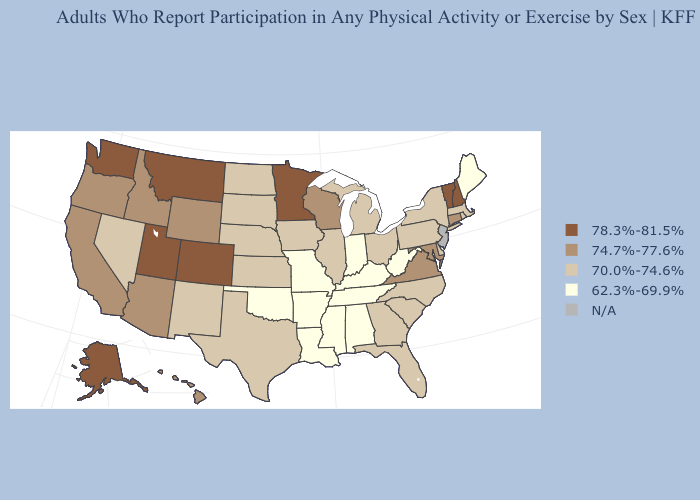Which states hav the highest value in the West?
Keep it brief. Alaska, Colorado, Montana, Utah, Washington. Among the states that border Michigan , does Wisconsin have the highest value?
Concise answer only. Yes. Among the states that border Rhode Island , which have the highest value?
Answer briefly. Connecticut. Does the first symbol in the legend represent the smallest category?
Keep it brief. No. What is the value of Nebraska?
Answer briefly. 70.0%-74.6%. Name the states that have a value in the range N/A?
Answer briefly. New Jersey. Among the states that border New Jersey , which have the highest value?
Concise answer only. Delaware, New York, Pennsylvania. Does the first symbol in the legend represent the smallest category?
Quick response, please. No. Does New Mexico have the lowest value in the West?
Be succinct. Yes. Among the states that border Missouri , which have the highest value?
Short answer required. Illinois, Iowa, Kansas, Nebraska. Which states have the highest value in the USA?
Concise answer only. Alaska, Colorado, Minnesota, Montana, New Hampshire, Utah, Vermont, Washington. What is the value of North Carolina?
Answer briefly. 70.0%-74.6%. Does Nevada have the lowest value in the West?
Give a very brief answer. Yes. What is the highest value in states that border Maryland?
Quick response, please. 74.7%-77.6%. 